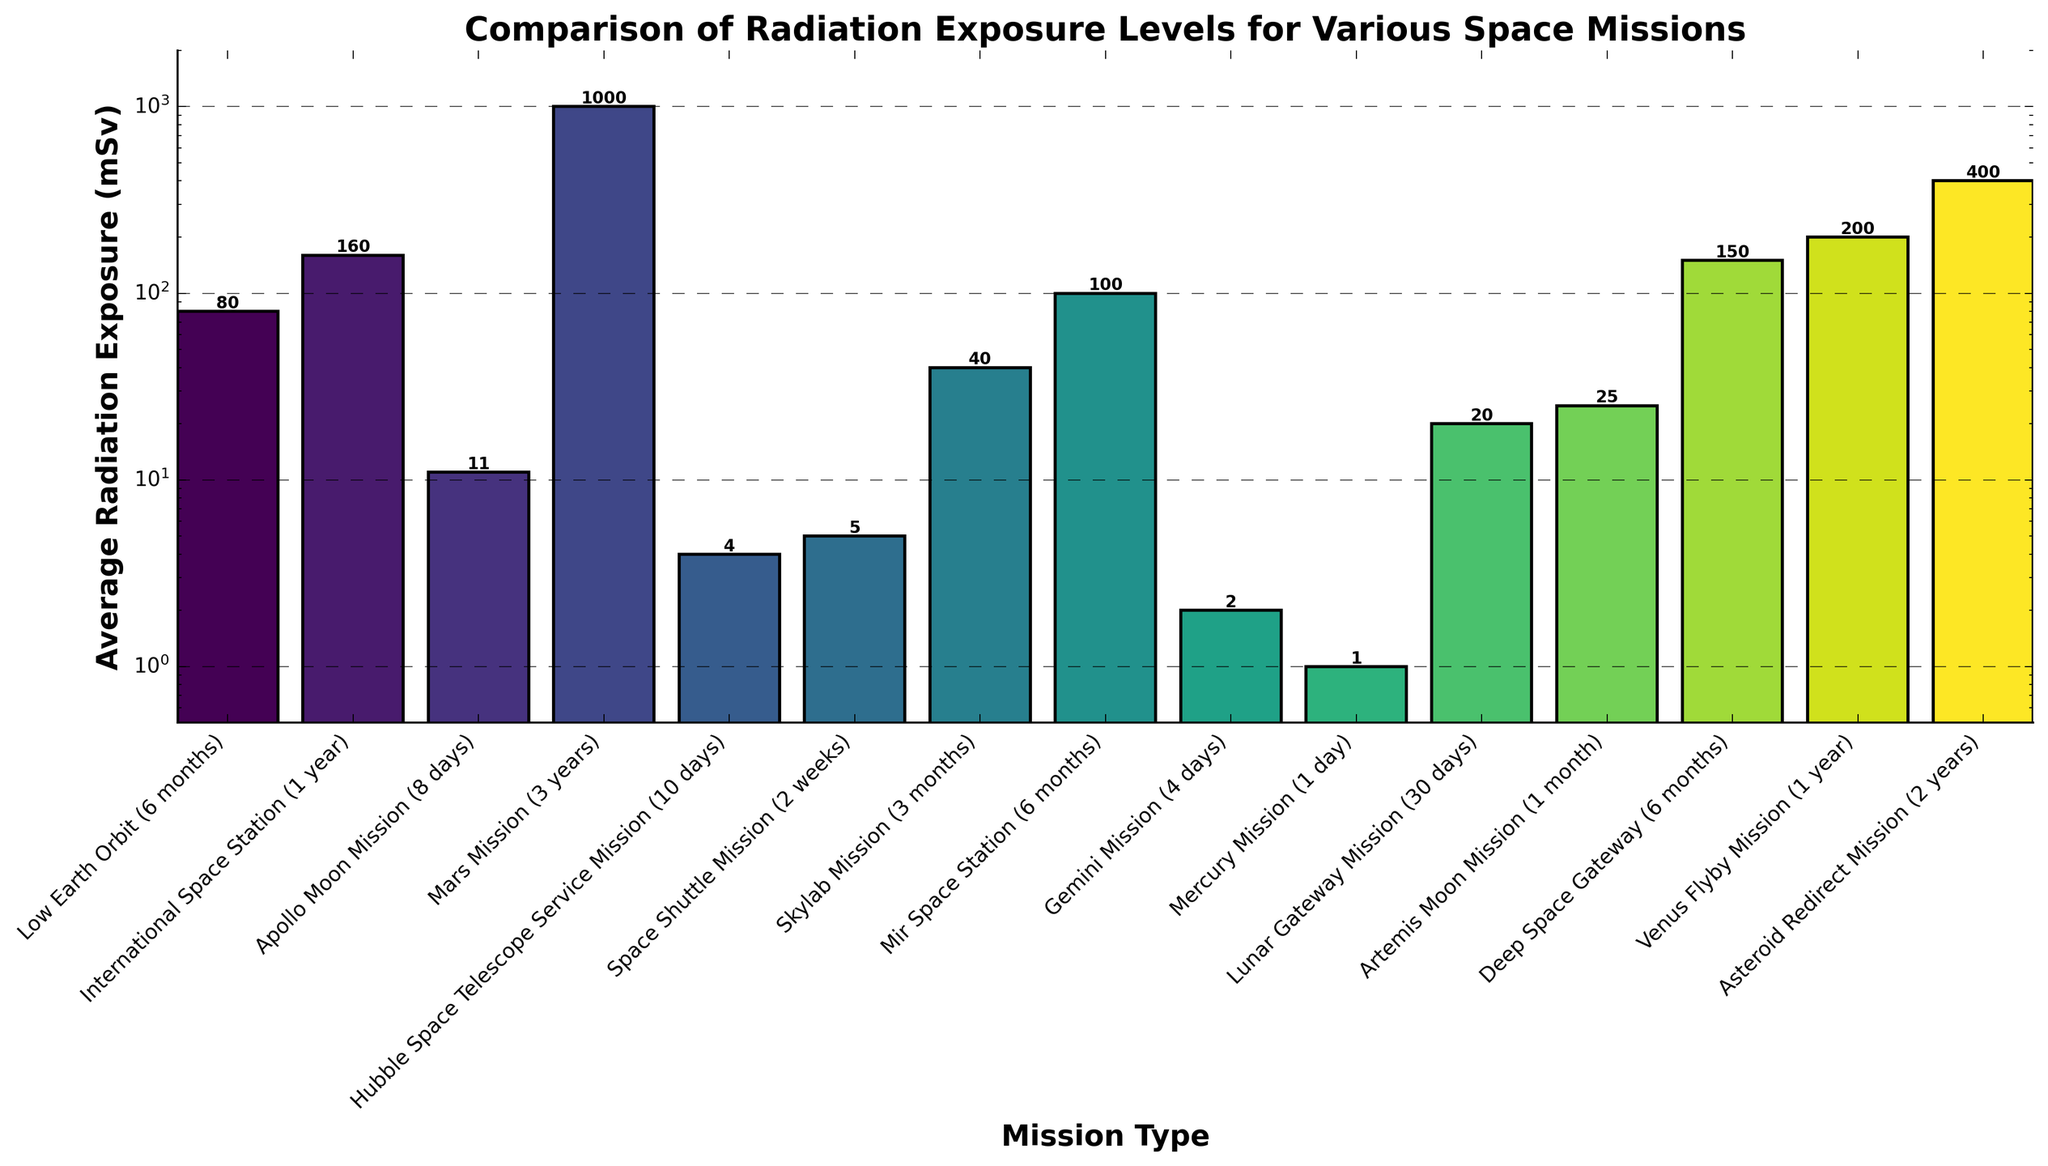Which space mission has the highest average radiation exposure? The highest bar represents the Mars Mission (3 years) at 1000 mSv.
Answer: Mars Mission (3 years) Which mission type has a lower average radiation exposure, Skylab Mission (3 months) or Mir Space Station (6 months)? Compare the heights of the bars for Skylab Mission (40 mSv) and Mir Space Station (100 mSv). Skylab Mission is lower.
Answer: Skylab Mission (3 months) What is the difference in average radiation exposure between the Apollo Moon Mission (8 days) and the Artemis Moon Mission (1 month)? Apollo Moon Mission has 11 mSv and Artemis Moon Mission has 25 mSv. The difference is 25 - 11 = 14 mSv.
Answer: 14 mSv How does the average radiation exposure for the Hubble Space Telescope Service Mission (10 days) compare to the Space Shuttle Mission (2 weeks)? The bars show Hubble Space Telescope Service Mission has 4 mSv, and Space Shuttle Mission has 5 mSv. Hubble service mission is lower.
Answer: Hubble Space Telescope Service Mission (10 days) What is the sum of the average radiation exposures for the International Space Station (1 year), Skylab Mission (3 months), and the Lunar Gateway Mission (30 days)? The values are ISS: 160 mSv, Skylab: 40 mSv, Lunar Gateway: 20 mSv. Sum = 160 + 40 + 20 = 220 mSv.
Answer: 220 mSv Which mission has the lowest average radiation exposure? The shortest bar represents the Mercury Mission (1 day) at 1 mSv.
Answer: Mercury Mission (1 day) Compare the average radiation exposures of the Deep Space Gateway (6 months) and Venus Flyby Mission (1 year). Which one is higher? Deep Space Gateway is 150 mSv and Venus Flyby Mission is 200 mSv. Venus Flyby Mission is higher.
Answer: Venus Flyby Mission (1 year) How much more average radiation exposure do astronauts experience on a Mars Mission (3 years) compared to Low Earth Orbit (6 months)? Mars Mission has 1000 mSv and Low Earth Orbit has 80 mSv. 1000 - 80 = 920 mSv.
Answer: 920 mSv What is the average radiation exposure for the missions that last around one month (Artemis Moon Mission and Lunar Gateway Mission)? The Artemis Moon Mission is 25 mSv and Lunar Gateway Mission is 20 mSv. Average = (25 + 20) / 2 = 22.5 mSv.
Answer: 22.5 mSv How does the radiation exposure for the Asteroid Redirect Mission (2 years) compare to the Apollo Moon Mission (8 days)? Asteroid Redirect Mission is 400 mSv, and Apollo Moon Mission is 11 mSv. Asteroid Redirect Mission is significantly higher.
Answer: Asteroid Redirect Mission (2 years) 